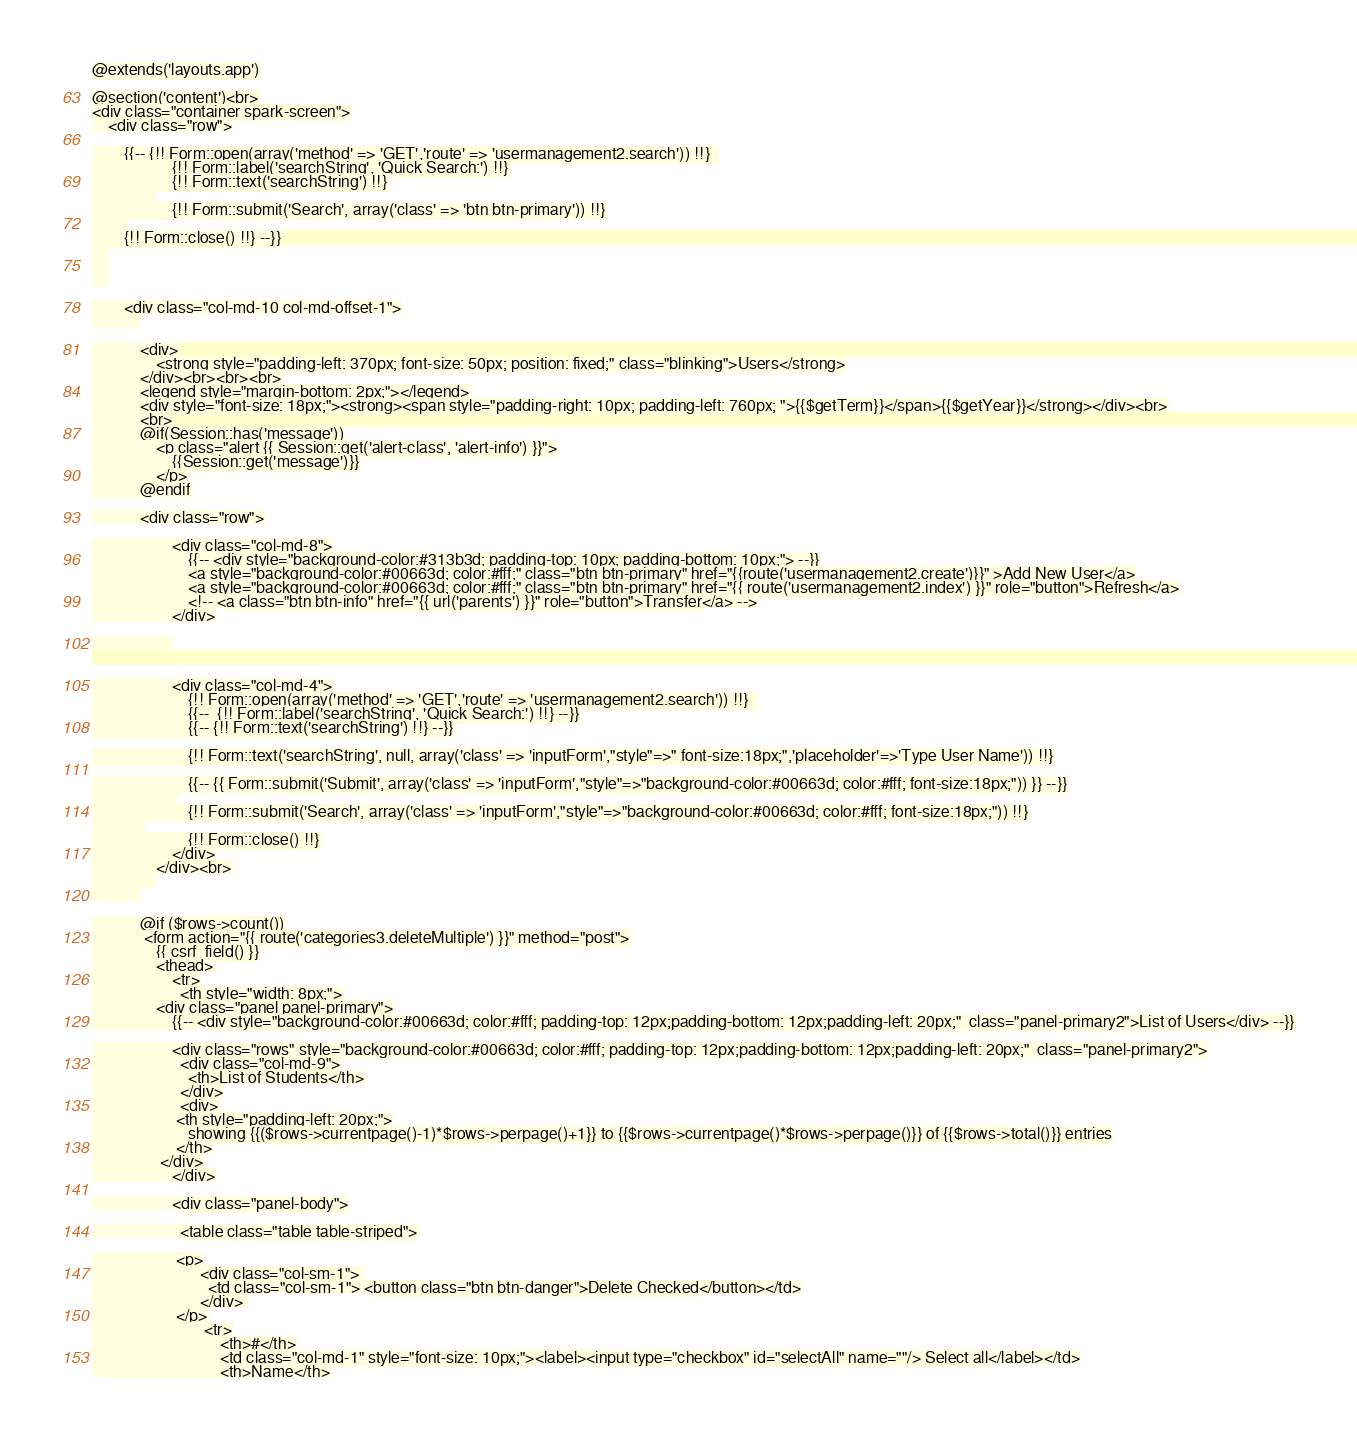Convert code to text. <code><loc_0><loc_0><loc_500><loc_500><_PHP_>@extends('layouts.app')

@section('content')<br>
<div class="container spark-screen">
    <div class="row">

		{{-- {!! Form::open(array('method' => 'GET','route' => 'usermanagement2.search')) !!}  
		            {!! Form::label('searchString', 'Quick Search:') !!}
		            {!! Form::text('searchString') !!}
		     	
					{!! Form::submit('Search', array('class' => 'btn btn-primary')) !!}
		 
		{!! Form::close() !!} --}}
	
	
	

        <div class="col-md-10 col-md-offset-1">
	        

	        <div>
	       		<strong style="padding-left: 370px; font-size: 50px; position: fixed;" class="blinking">Users</strong>
	       	</div><br><br><br>
	       	<legend style="margin-bottom: 2px;"></legend>
	       	<div style="font-size: 18px;"><strong><span style="padding-right: 10px; padding-left: 760px; ">{{$getTerm}}</span>{{$getYear}}</strong></div><br>
	       	<br>
	        @if(Session::has('message'))
			    <p class="alert {{ Session::get('alert-class', 'alert-info') }}">
			        {{Session::get('message')}}
			    </p>
			@endif

			<div class="row">

					<div class="col-md-8">
						{{-- <div style="background-color:#313b3d; padding-top: 10px; padding-bottom: 10px;"> --}}
						<a style="background-color:#00663d; color:#fff;" class="btn btn-primary" href="{{route('usermanagement2.create')}}" >Add New User</a>
						<a style="background-color:#00663d; color:#fff;" class="btn btn-primary" href="{{ route('usermanagement2.index') }}" role="button">Refresh</a>
						<!-- <a class="btn btn-info" href="{{ url('parents') }}" role="button">Transfer</a> -->
					</div>

					


					<div class="col-md-4">
						{!! Form::open(array('method' => 'GET','route' => 'usermanagement2.search')) !!}  
			            {{--  {!! Form::label('searchString', 'Quick Search:') !!} --}}
			            {{-- {!! Form::text('searchString') !!} --}}

			            {!! Form::text('searchString', null, array('class' => 'inputForm',"style"=>" font-size:18px;",'placeholder'=>'Type User Name')) !!}

			            {{-- {{ Form::submit('Submit', array('class' => 'inputForm',"style"=>"background-color:#00663d; color:#fff; font-size:18px;")) }} --}}
			     	 
						{!! Form::submit('Search', array('class' => 'inputForm',"style"=>"background-color:#00663d; color:#fff; font-size:18px;")) !!}
			 
			            {!! Form::close() !!}
					</div>
				</div><br>
				
			

			@if ($rows->count())
             <form action="{{ route('categories3.deleteMultiple') }}" method="post">
                {{ csrf_field() }}
                <thead>
                    <tr>
                      <th style="width: 8px;">
	            <div class="panel panel-primary">
	                {{-- <div style="background-color:#00663d; color:#fff; padding-top: 12px;padding-bottom: 12px;padding-left: 20px;"  class="panel-primary2">List of Users</div> --}}

	                <div class="rows" style="background-color:#00663d; color:#fff; padding-top: 12px;padding-bottom: 12px;padding-left: 20px;"  class="panel-primary2">
                      <div class="col-md-9">
	                	<th>List of Students</th>
                      </div>
                      <div>
                     <th style="padding-left: 20px;">
                     	showing {{($rows->currentpage()-1)*$rows->perpage()+1}} to {{$rows->currentpage()*$rows->perpage()}} of {{$rows->total()}} entries
                     </th>
                 </div>
	                </div>

	                <div class="panel-body">

	                  <table class="table table-striped">

	                 <p>
                           <div class="col-sm-1"> 
		                     <td class="col-sm-1"> <button class="btn btn-danger">Delete Checked</button></td>
		                   </div> 
		             </p>
							<tr>
								<th>#</th>
								<td class="col-md-1" style="font-size: 10px;"><label><input type="checkbox" id="selectAll" name=""/> Select all</label></td>
								<th>Name</th></code> 